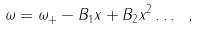Convert formula to latex. <formula><loc_0><loc_0><loc_500><loc_500>\omega = \omega _ { + } - B _ { 1 } x + B _ { 2 } x ^ { 2 } \dots \text { } ,</formula> 